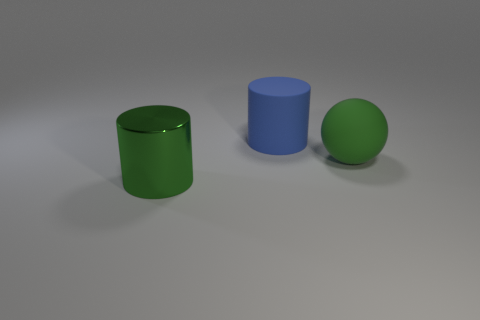Are there fewer green cylinders that are to the right of the big green ball than tiny brown cubes?
Your response must be concise. No. What is the color of the metal cylinder that is the same size as the blue matte cylinder?
Provide a succinct answer. Green. How many other matte things have the same shape as the green matte object?
Provide a succinct answer. 0. What is the color of the cylinder on the left side of the matte cylinder?
Provide a succinct answer. Green. How many rubber things are large spheres or green things?
Your answer should be very brief. 1. There is a big thing that is the same color as the large sphere; what is its shape?
Provide a short and direct response. Cylinder. How many green shiny cylinders have the same size as the green rubber ball?
Your answer should be compact. 1. There is a object that is on the left side of the green rubber object and behind the metallic cylinder; what color is it?
Your response must be concise. Blue. What number of objects are either big rubber spheres or metal cylinders?
Your answer should be very brief. 2. How many small things are either red metallic cylinders or shiny objects?
Ensure brevity in your answer.  0. 